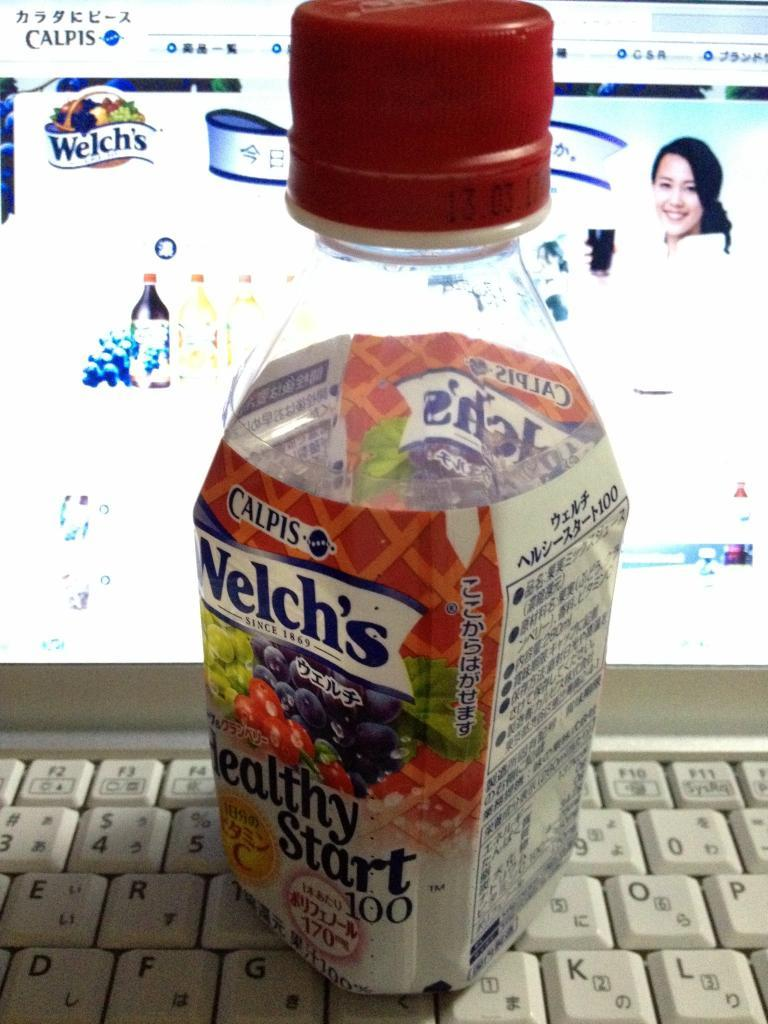<image>
Present a compact description of the photo's key features. A bottle of Welch's Healthy Start fruit juice is on a keyboard. 